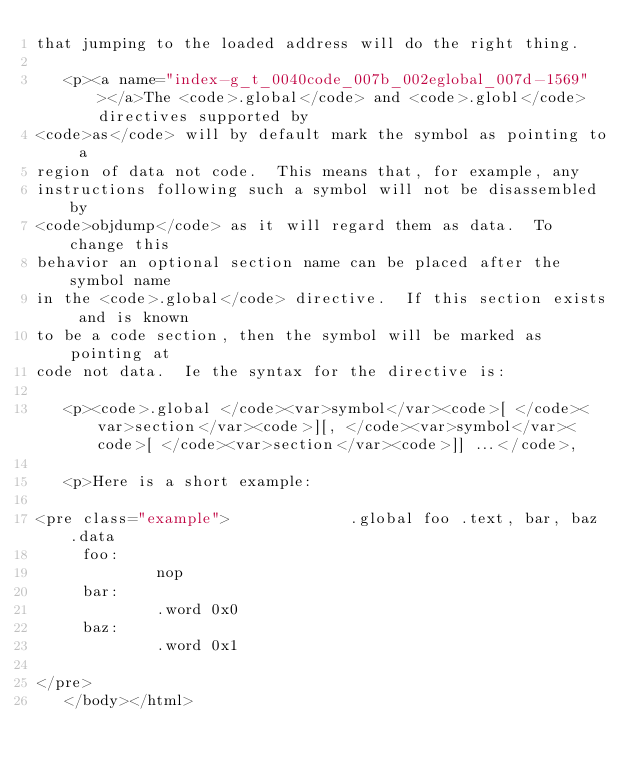Convert code to text. <code><loc_0><loc_0><loc_500><loc_500><_HTML_>that jumping to the loaded address will do the right thing.

   <p><a name="index-g_t_0040code_007b_002eglobal_007d-1569"></a>The <code>.global</code> and <code>.globl</code> directives supported by
<code>as</code> will by default mark the symbol as pointing to a
region of data not code.  This means that, for example, any
instructions following such a symbol will not be disassembled by
<code>objdump</code> as it will regard them as data.  To change this
behavior an optional section name can be placed after the symbol name
in the <code>.global</code> directive.  If this section exists and is known
to be a code section, then the symbol will be marked as pointing at
code not data.  Ie the syntax for the directive is:

   <p><code>.global </code><var>symbol</var><code>[ </code><var>section</var><code>][, </code><var>symbol</var><code>[ </code><var>section</var><code>]] ...</code>,

   <p>Here is a short example:

<pre class="example">             .global foo .text, bar, baz .data
     foo:
             nop
     bar:
             .word 0x0
     baz:
             .word 0x1
     
</pre>
   </body></html>

</code> 